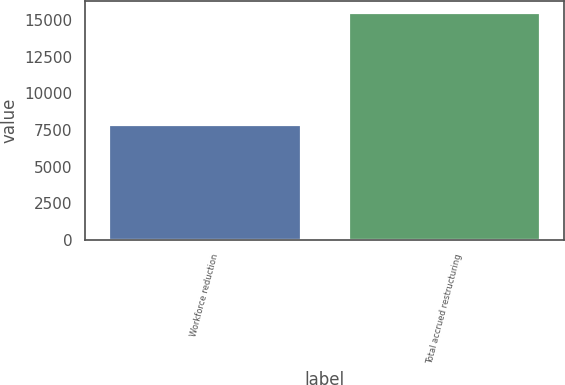<chart> <loc_0><loc_0><loc_500><loc_500><bar_chart><fcel>Workforce reduction<fcel>Total accrued restructuring<nl><fcel>7824<fcel>15512<nl></chart> 